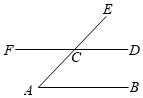How can properties of triangles help in understanding more about point C in the diagram? Point C is the intersection of lines AE and DF, and is crucial in forming two triangles in the diagram: triangle AEC and triangle DFC. Using properties like the sum of angles in a triangle, which is always 180°, we can analyze these triangles to find missing angles or validate known angles. For instance, knowing angles at point C and one of the angles in these triangles can help us deduce the third angle, enriching our understanding of spatial relationships and angle properties in the geometry of the diagram. 